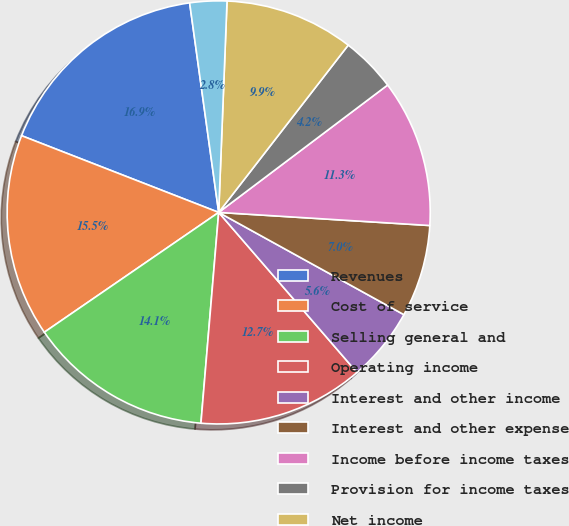<chart> <loc_0><loc_0><loc_500><loc_500><pie_chart><fcel>Revenues<fcel>Cost of service<fcel>Selling general and<fcel>Operating income<fcel>Interest and other income<fcel>Interest and other expense<fcel>Income before income taxes<fcel>Provision for income taxes<fcel>Net income<fcel>Less Net income attributable<nl><fcel>16.9%<fcel>15.49%<fcel>14.08%<fcel>12.68%<fcel>5.63%<fcel>7.04%<fcel>11.27%<fcel>4.23%<fcel>9.86%<fcel>2.82%<nl></chart> 